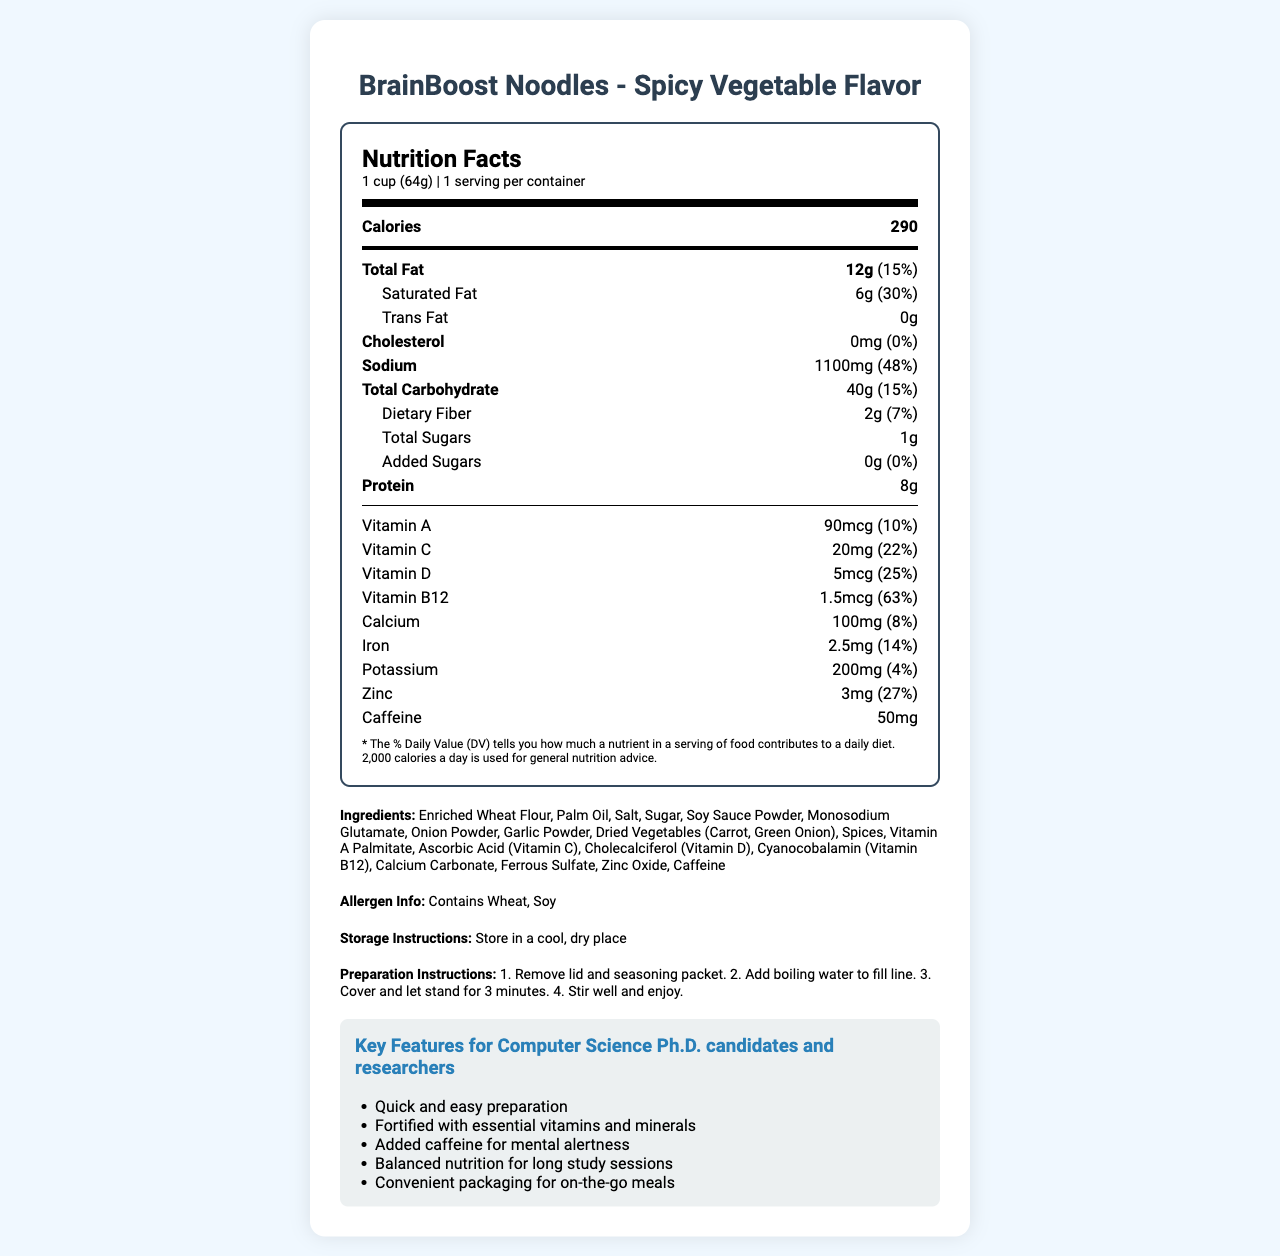what is the serving size of the instant noodle cup? The serving size is specified at the beginning of the Nutrition Facts, listed as "1 cup (64g)".
Answer: 1 cup (64g) How many servings are there per container? The servings per container are clearly indicated as 1.
Answer: 1 What is the total fat content and its percentage daily value? The document states "Total Fat" content is 12g, which is 15% of the daily value.
Answer: 12g, 15% How much sodium does a serving contain? The Nutrition Facts indicate that sodium content is 1100mg.
Answer: 1100mg Does the product contain any cholesterol? The "Cholesterol" section specifies 0mg, which is 0% of the daily value.
Answer: No List two spices mentioned in the ingredients list. The ingredients list includes "Onion Powder" and "Garlic Powder".
Answer: Onion Powder, Garlic Powder Which vitamin has the highest daily value percentage? A. Vitamin A B. Vitamin C C. Vitamin D D. Vitamin B12 Vitamin B12 has a daily value percentage of 63%, which is the highest among the listed vitamins.
Answer: D. Vitamin B12 What is the amount of dietary fiber in the product? A. 2g B. 4g C. 6g D. 8g The Nutrition Facts label shows that dietary fiber content is 2g.
Answer: A. 2g Does this product contain trans fat? The trans fat content is listed as 0g in the Nutrition Facts.
Answer: No Is this product suitable for people with wheat allergies? The allergen information specifies that the product contains wheat.
Answer: No Summarize the main features of this document. The document provides comprehensive nutritional details, lists the ingredients, allergen info, storage, and preparation instructions, and highlights its suitability as a quick, nutritious meal for intensive study sessions.
Answer: The document details the nutritional information for BrainBoost Noodles - Spicy Vegetable Flavor. It includes serving size, calories, macronutrients, vitamins, and minerals. It highlights key features such as quick preparation, essential vitamins and minerals, added caffeine, balanced nutrition for study sessions, and convenience. The product targets computer science Ph.D. candidates and researchers. Where is the product sourced from? The document does not provide sourcing information.
Answer: Not enough information How much protein is in a serving? The protein content per serving is listed as 8g.
Answer: 8g How many milligrams of iron are in a serving, and what is its percentage daily value? The document states 2.5mg of iron per serving, which is 14% of the daily value.
Answer: 2.5mg, 14% Identify a unique aspect of this instant noodle cup that caters specifically to researchers. One of the key features specifically highlights the addition of caffeine to help with mental alertness during long study sessions.
Answer: Added caffeine for mental alertness List the preparation instructions for the noodle cup. The steps outlined on the document are: remove lid and seasoning packet, add boiling water to fill line, cover and let stand for 3 minutes, then stir well and enjoy.
Answer: 1. Remove lid and seasoning packet. 2. Add boiling water to fill line. 3. Cover and let stand for 3 minutes. 4. Stir well and enjoy. How much caffeine does the product contain? The document lists caffeine content as 50mg.
Answer: 50mg Does the product contain soy? The allergen information states that the product contains soy.
Answer: Yes How many key features are listed for the product? The document outlines five key features of the product aimed at its target audience.
Answer: Five 